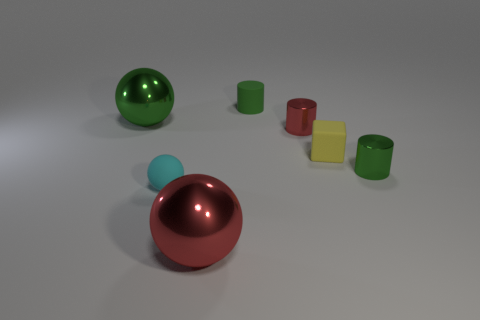There is a green object that is made of the same material as the yellow thing; what size is it?
Offer a very short reply. Small. There is a matte object right of the red metallic cylinder; what size is it?
Your response must be concise. Small. What number of metallic spheres have the same size as the matte block?
Ensure brevity in your answer.  0. What size is the other cylinder that is the same color as the small matte cylinder?
Your answer should be compact. Small. Is there a large rubber object that has the same color as the tiny matte cylinder?
Your response must be concise. No. There is a ball that is the same size as the green matte cylinder; what color is it?
Make the answer very short. Cyan. Is the color of the rubber ball the same as the big thing behind the red shiny ball?
Offer a terse response. No. The tiny sphere has what color?
Your answer should be compact. Cyan. There is a cylinder that is behind the green sphere; what is it made of?
Your answer should be compact. Rubber. There is a cyan object that is the same shape as the large green metallic thing; what is its size?
Provide a short and direct response. Small. 